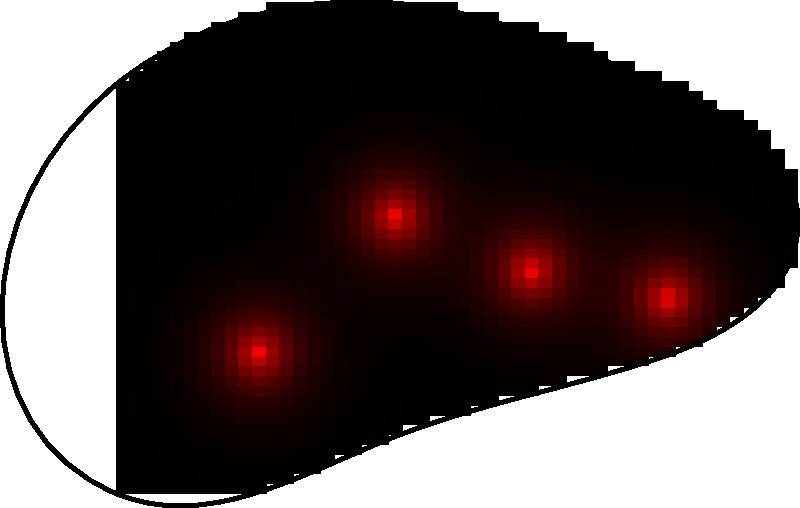Analyze the heat map of foot pressure distribution during walking. Which area of the foot experiences the highest pressure, and what implications does this have for gait analysis and potential cybersecurity applications in biometric identification? 1. Observe the heat map: The red areas indicate higher pressure, while cooler colors (darker areas) represent lower pressure.

2. Identify high-pressure areas: The brightest red spots are located in the ball of the foot (metatarsal area) and the heel.

3. Analyze pressure distribution: The highest pressure is concentrated in the metatarsal area, followed by the heel. The arch of the foot shows lower pressure.

4. Gait analysis implications:
   a) The pressure distribution indicates a typical heel-to-toe walking pattern.
   b) High pressure in the metatarsal area suggests proper push-off during the gait cycle.
   c) The arch pressure can indicate the type of foot (normal, high, or low arch).

5. Cybersecurity applications in biometric identification:
   a) Unique pressure patterns: Each individual has a distinct foot pressure distribution.
   b) Gait recognition: Pressure patterns combined with temporal data can create a unique gait signature.
   c) Multi-factor authentication: Foot pressure patterns can be used alongside other biometric data for enhanced security.
   d) Continuous authentication: Gait analysis can provide ongoing verification in secure environments.

6. Potential challenges:
   a) Data collection: Specialized sensors or smart floors would be required.
   b) Pattern variability: Gait patterns may change due to footwear, injuries, or terrain.
   c) Privacy concerns: Continuous gait monitoring raises ethical questions.

7. Advantages for cybersecurity:
   a) Difficult to replicate: Unlike static biometrics, gait patterns are challenging to forge.
   b) Non-intrusive: Gait analysis can be performed without direct user interaction.
   c) Combination with other security measures: Enhances overall system security.
Answer: The metatarsal area experiences the highest pressure, implying potential use in gait-based biometric identification for continuous, non-intrusive authentication in cybersecurity applications. 